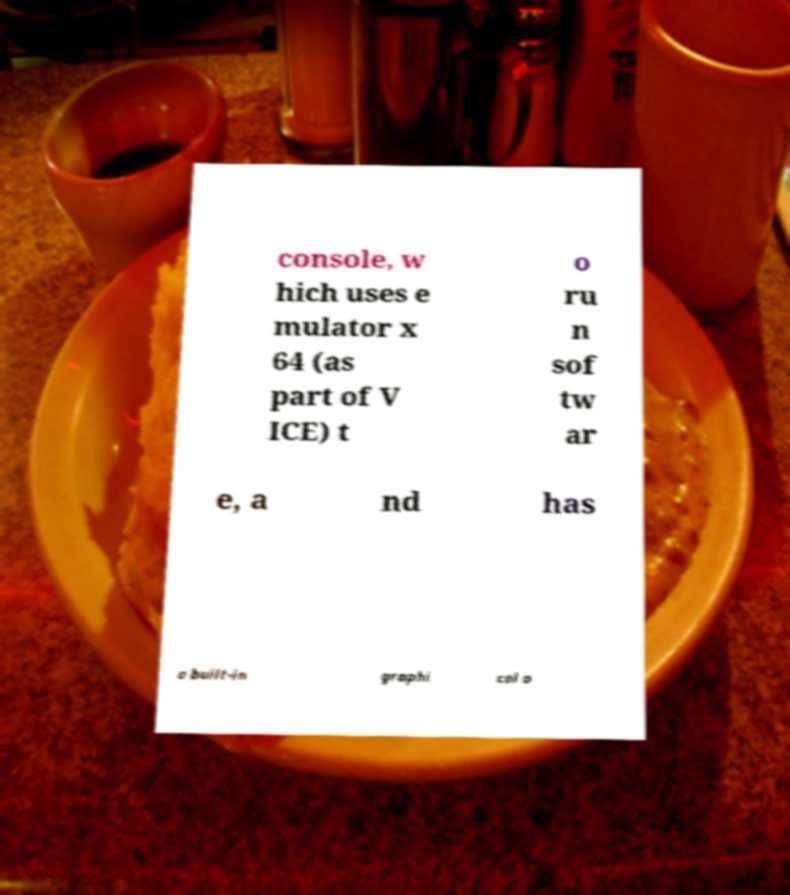For documentation purposes, I need the text within this image transcribed. Could you provide that? console, w hich uses e mulator x 64 (as part of V ICE) t o ru n sof tw ar e, a nd has a built-in graphi cal o 